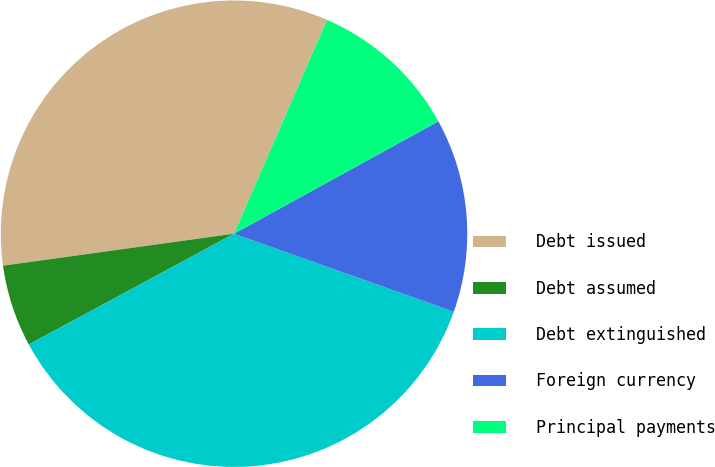Convert chart. <chart><loc_0><loc_0><loc_500><loc_500><pie_chart><fcel>Debt issued<fcel>Debt assumed<fcel>Debt extinguished<fcel>Foreign currency<fcel>Principal payments<nl><fcel>33.72%<fcel>5.69%<fcel>36.69%<fcel>13.43%<fcel>10.47%<nl></chart> 